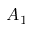<formula> <loc_0><loc_0><loc_500><loc_500>A _ { 1 }</formula> 